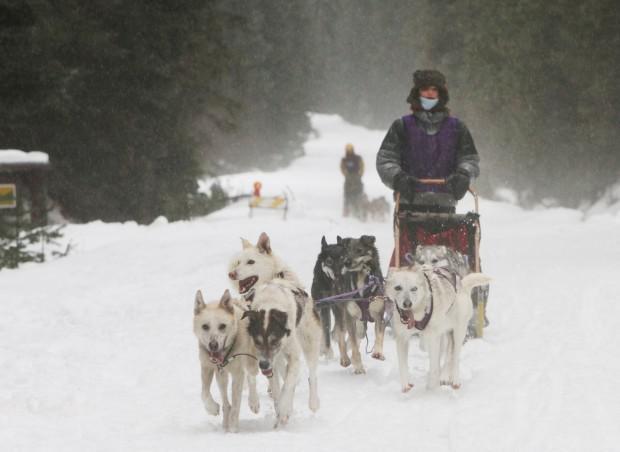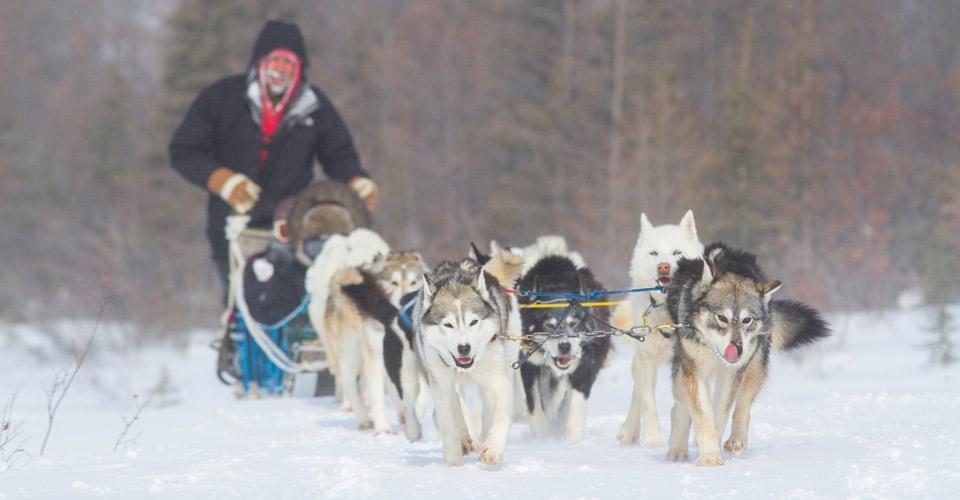The first image is the image on the left, the second image is the image on the right. Analyze the images presented: Is the assertion "Three non-canine mammals are visible." valid? Answer yes or no. Yes. The first image is the image on the left, the second image is the image on the right. Examine the images to the left and right. Is the description "The dogs are to the right of the sled in both pictures." accurate? Answer yes or no. No. 